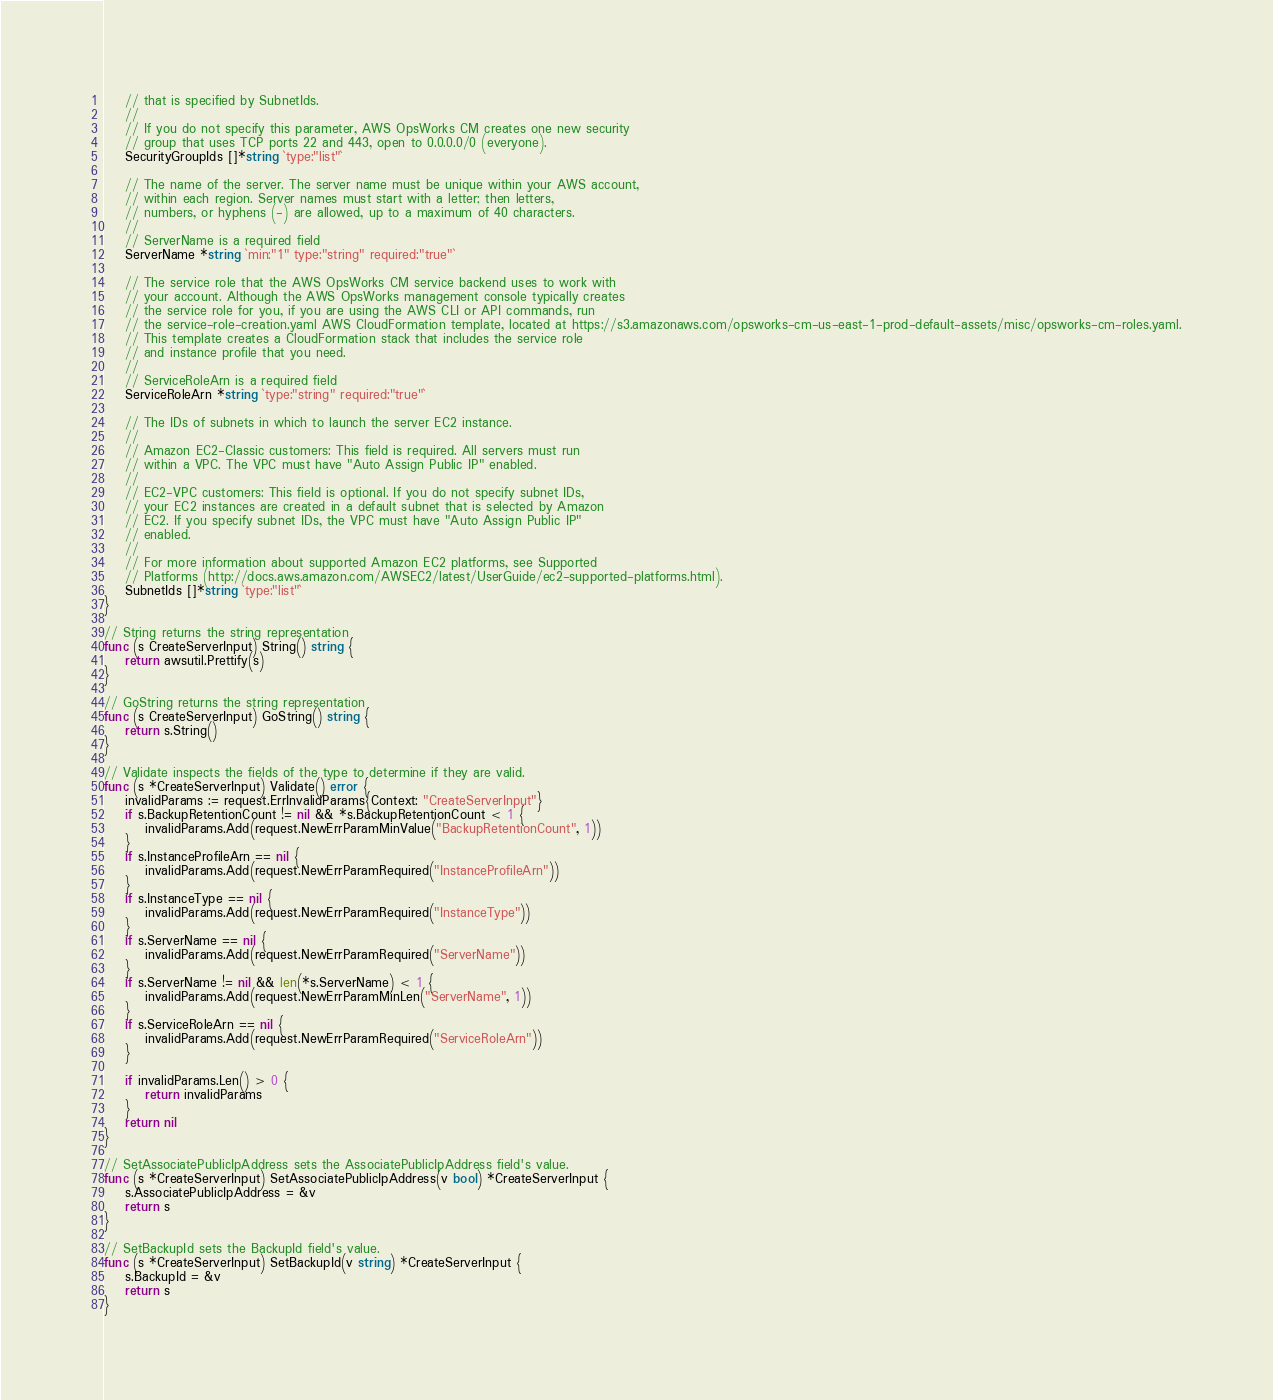Convert code to text. <code><loc_0><loc_0><loc_500><loc_500><_Go_>	// that is specified by SubnetIds.
	//
	// If you do not specify this parameter, AWS OpsWorks CM creates one new security
	// group that uses TCP ports 22 and 443, open to 0.0.0.0/0 (everyone).
	SecurityGroupIds []*string `type:"list"`

	// The name of the server. The server name must be unique within your AWS account,
	// within each region. Server names must start with a letter; then letters,
	// numbers, or hyphens (-) are allowed, up to a maximum of 40 characters.
	//
	// ServerName is a required field
	ServerName *string `min:"1" type:"string" required:"true"`

	// The service role that the AWS OpsWorks CM service backend uses to work with
	// your account. Although the AWS OpsWorks management console typically creates
	// the service role for you, if you are using the AWS CLI or API commands, run
	// the service-role-creation.yaml AWS CloudFormation template, located at https://s3.amazonaws.com/opsworks-cm-us-east-1-prod-default-assets/misc/opsworks-cm-roles.yaml.
	// This template creates a CloudFormation stack that includes the service role
	// and instance profile that you need.
	//
	// ServiceRoleArn is a required field
	ServiceRoleArn *string `type:"string" required:"true"`

	// The IDs of subnets in which to launch the server EC2 instance.
	//
	// Amazon EC2-Classic customers: This field is required. All servers must run
	// within a VPC. The VPC must have "Auto Assign Public IP" enabled.
	//
	// EC2-VPC customers: This field is optional. If you do not specify subnet IDs,
	// your EC2 instances are created in a default subnet that is selected by Amazon
	// EC2. If you specify subnet IDs, the VPC must have "Auto Assign Public IP"
	// enabled.
	//
	// For more information about supported Amazon EC2 platforms, see Supported
	// Platforms (http://docs.aws.amazon.com/AWSEC2/latest/UserGuide/ec2-supported-platforms.html).
	SubnetIds []*string `type:"list"`
}

// String returns the string representation
func (s CreateServerInput) String() string {
	return awsutil.Prettify(s)
}

// GoString returns the string representation
func (s CreateServerInput) GoString() string {
	return s.String()
}

// Validate inspects the fields of the type to determine if they are valid.
func (s *CreateServerInput) Validate() error {
	invalidParams := request.ErrInvalidParams{Context: "CreateServerInput"}
	if s.BackupRetentionCount != nil && *s.BackupRetentionCount < 1 {
		invalidParams.Add(request.NewErrParamMinValue("BackupRetentionCount", 1))
	}
	if s.InstanceProfileArn == nil {
		invalidParams.Add(request.NewErrParamRequired("InstanceProfileArn"))
	}
	if s.InstanceType == nil {
		invalidParams.Add(request.NewErrParamRequired("InstanceType"))
	}
	if s.ServerName == nil {
		invalidParams.Add(request.NewErrParamRequired("ServerName"))
	}
	if s.ServerName != nil && len(*s.ServerName) < 1 {
		invalidParams.Add(request.NewErrParamMinLen("ServerName", 1))
	}
	if s.ServiceRoleArn == nil {
		invalidParams.Add(request.NewErrParamRequired("ServiceRoleArn"))
	}

	if invalidParams.Len() > 0 {
		return invalidParams
	}
	return nil
}

// SetAssociatePublicIpAddress sets the AssociatePublicIpAddress field's value.
func (s *CreateServerInput) SetAssociatePublicIpAddress(v bool) *CreateServerInput {
	s.AssociatePublicIpAddress = &v
	return s
}

// SetBackupId sets the BackupId field's value.
func (s *CreateServerInput) SetBackupId(v string) *CreateServerInput {
	s.BackupId = &v
	return s
}
</code> 